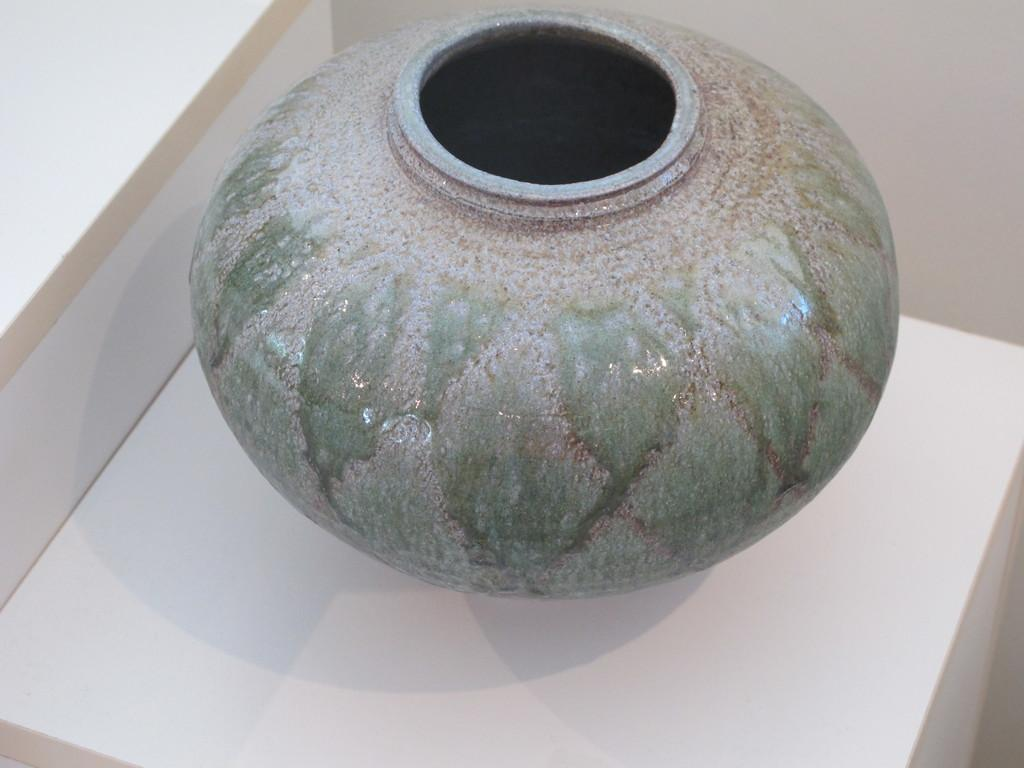What object is the main focus of the image? There is a porcelain pot in the image. Where is the pot located? The pot is placed on a desk. Can you describe the color of the desk? The desk is white in color. What can be seen in the background of the image? There is a wall in the background of the image. How does the snail compare to the size of the porcelain pot in the image? There is no snail present in the image, so it cannot be compared to the size of the porcelain pot. Can you tell me how many giraffes are visible in the image? There are no giraffes present in the image. 